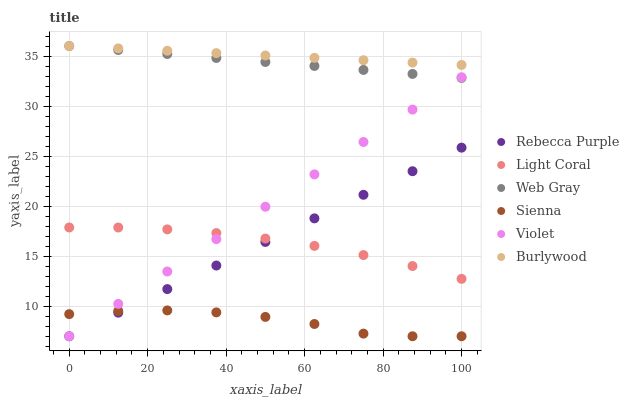Does Sienna have the minimum area under the curve?
Answer yes or no. Yes. Does Burlywood have the maximum area under the curve?
Answer yes or no. Yes. Does Web Gray have the minimum area under the curve?
Answer yes or no. No. Does Web Gray have the maximum area under the curve?
Answer yes or no. No. Is Burlywood the smoothest?
Answer yes or no. Yes. Is Sienna the roughest?
Answer yes or no. Yes. Is Web Gray the smoothest?
Answer yes or no. No. Is Web Gray the roughest?
Answer yes or no. No. Does Sienna have the lowest value?
Answer yes or no. Yes. Does Web Gray have the lowest value?
Answer yes or no. No. Does Burlywood have the highest value?
Answer yes or no. Yes. Does Light Coral have the highest value?
Answer yes or no. No. Is Sienna less than Light Coral?
Answer yes or no. Yes. Is Burlywood greater than Sienna?
Answer yes or no. Yes. Does Burlywood intersect Web Gray?
Answer yes or no. Yes. Is Burlywood less than Web Gray?
Answer yes or no. No. Is Burlywood greater than Web Gray?
Answer yes or no. No. Does Sienna intersect Light Coral?
Answer yes or no. No. 